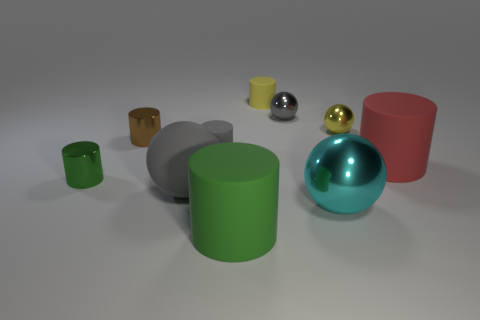How many gray balls must be subtracted to get 1 gray balls? 1 Subtract all small gray rubber cylinders. How many cylinders are left? 5 Subtract all brown cylinders. How many cylinders are left? 5 Subtract all balls. How many objects are left? 6 Subtract 1 spheres. How many spheres are left? 3 Subtract 0 red blocks. How many objects are left? 10 Subtract all brown spheres. Subtract all yellow blocks. How many spheres are left? 4 Subtract all yellow cylinders. How many blue balls are left? 0 Subtract all purple cubes. Subtract all tiny shiny things. How many objects are left? 6 Add 8 tiny metallic cylinders. How many tiny metallic cylinders are left? 10 